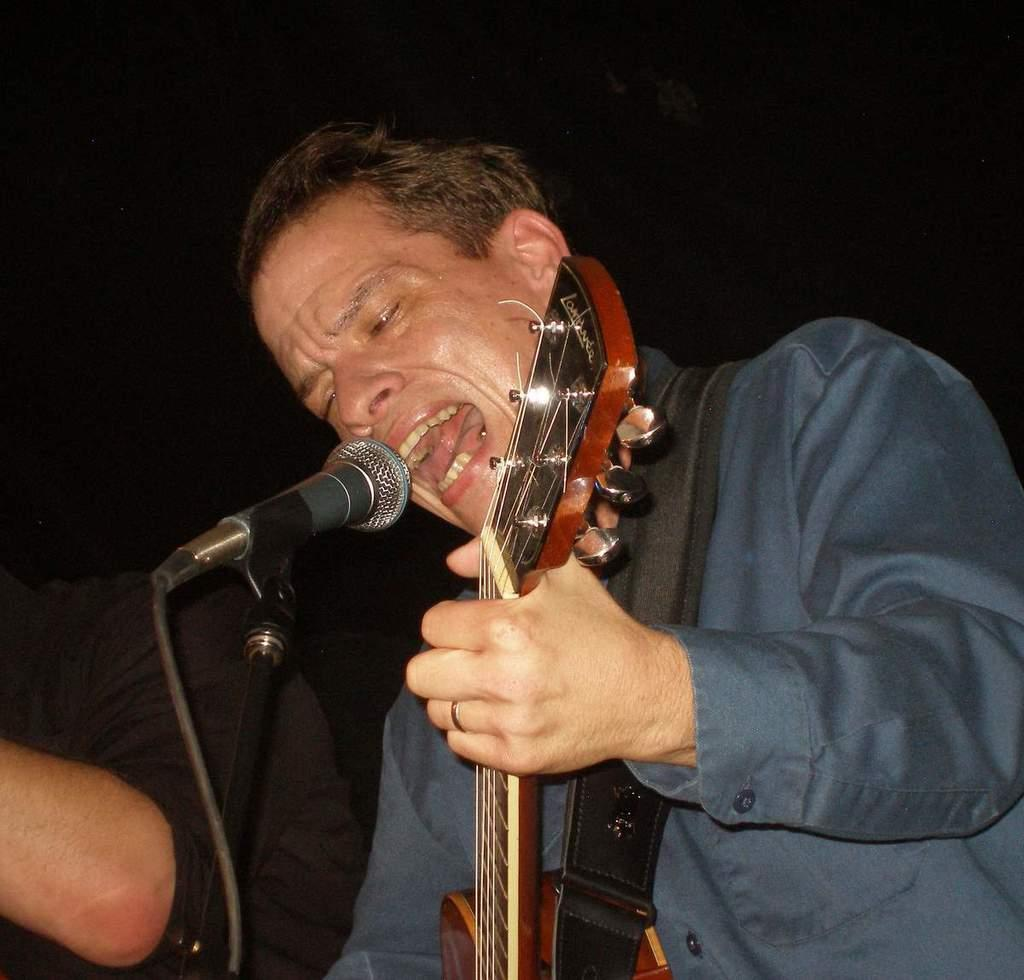What is the man in the image doing? The man is playing a guitar and singing. How is the man amplifying his voice while singing? The man is using a microphone while singing. Where are the scissors located in the image? There are no scissors present in the image. How many ladybugs can be seen on the man's guitar in the image? There are no ladybugs present in the image. 